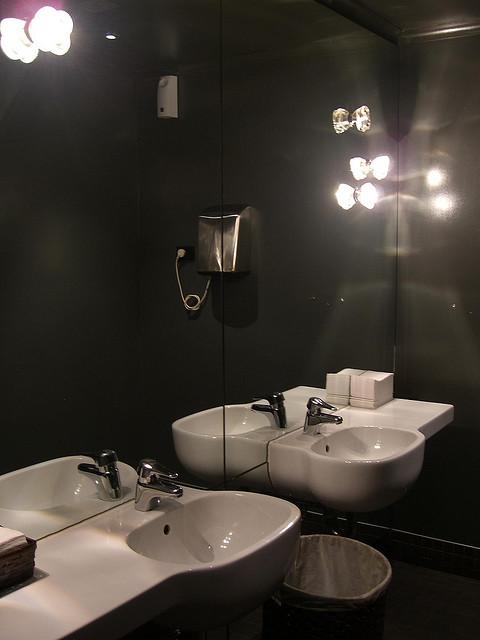What room is this?
Give a very brief answer. Bathroom. Where are the paper towels?
Quick response, please. Sink. Is there a toilet here?
Answer briefly. No. 